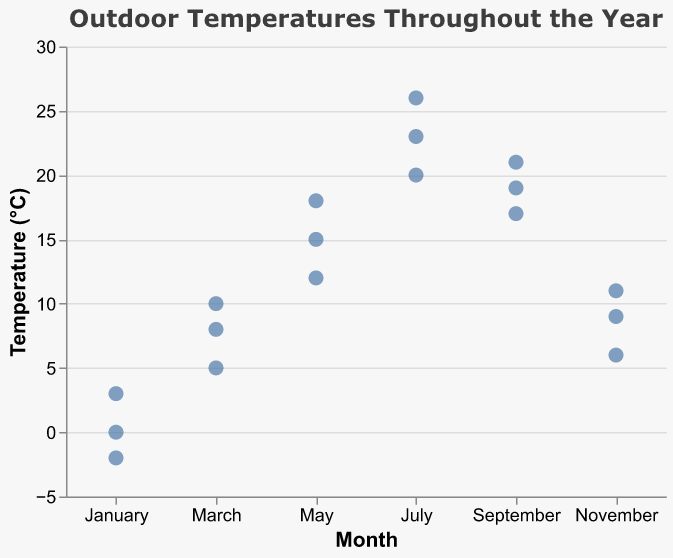what's the title of the plot? The title of the plot is written at the top and indicates what the plot is about.
Answer: Outdoor Temperatures Throughout the Year how many months are represented in the plot? By checking the x-axis, we see the months labeled: January, March, May, July, September, and November. Count these labels to get the answer.
Answer: Six how many temperature readings are there for the month of March? Look at the data points along the x-axis under "March" and count how many dots are present in that column.
Answer: Three what's the temperature range in July? Find the lowest and highest temperature points in July. The lowest temperature is 20°C and the highest is 26°C. Subtract the lowest from the highest to get the range.
Answer: 6°C which month has the highest recorded temperature? Look for the highest point on the y-axis and check which month it corresponds to on the x-axis.
Answer: July which month shows the most variation in temperatures? Notice the spread of points vertically for each month. The month with the widest spread between its highest and lowest points indicates the most variation.
Answer: July how does the average temperature in March compare to that in November? Average the temperatures in March: (5 + 8 + 10)/3 = 7.67°C. Average the temperatures in November: (6 + 9 + 11)/3 = 8.67°C. Compare the two averages.
Answer: November is warmer what's the median temperature in May? Look at the three temperature readings for May (12, 15, 18). The median is the middle value when the readings are sorted in order.
Answer: 15°C which month has the smallest temperature range? Calculate the temperature range for each month by subtracting the lowest from the highest reading for each month and determine the smallest. January: 5°C, March: 5°C, May: 6°C, July: 6°C, September: 4°C, November: 5°C.
Answer: September 